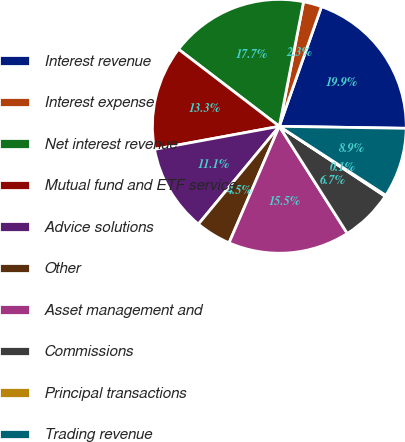Convert chart to OTSL. <chart><loc_0><loc_0><loc_500><loc_500><pie_chart><fcel>Interest revenue<fcel>Interest expense<fcel>Net interest revenue<fcel>Mutual fund and ETF service<fcel>Advice solutions<fcel>Other<fcel>Asset management and<fcel>Commissions<fcel>Principal transactions<fcel>Trading revenue<nl><fcel>19.86%<fcel>2.33%<fcel>17.67%<fcel>13.29%<fcel>11.1%<fcel>4.52%<fcel>15.48%<fcel>6.71%<fcel>0.14%<fcel>8.9%<nl></chart> 